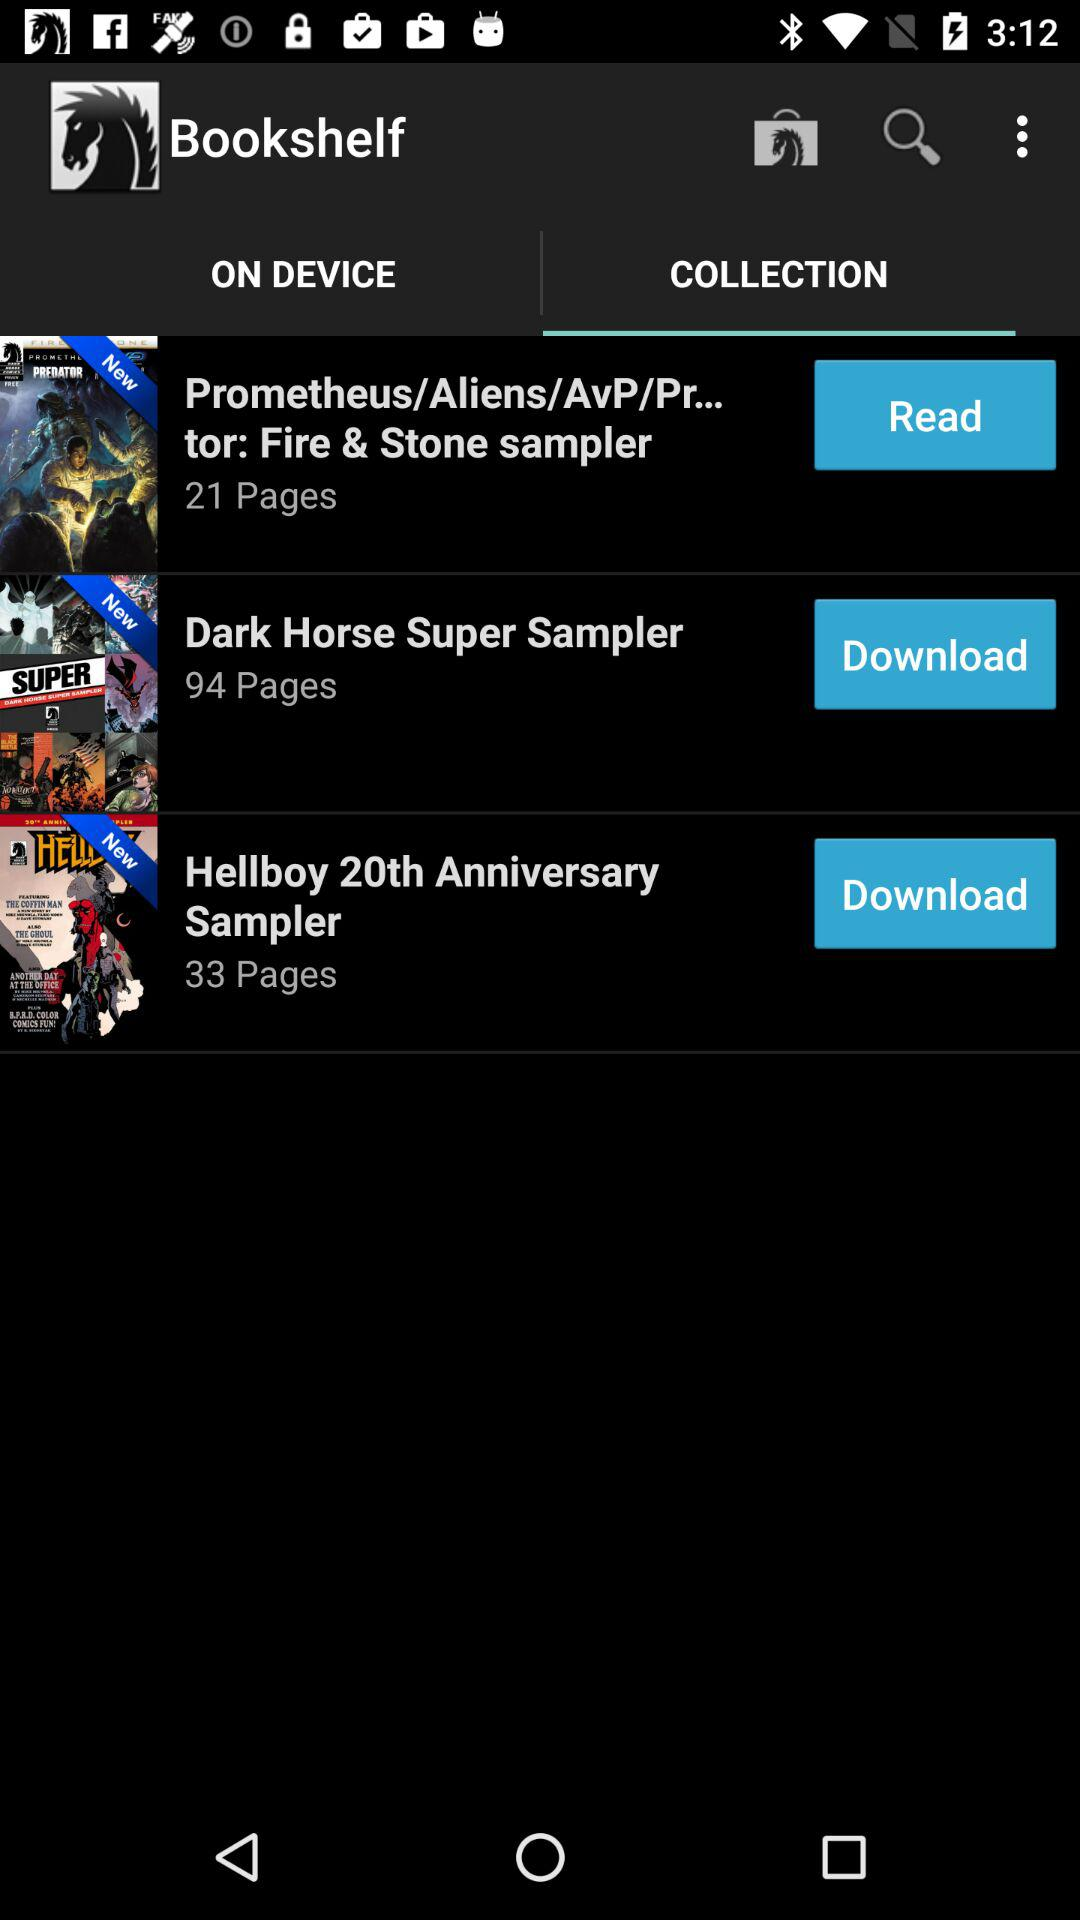How many pages are in the Dark Horse Super Sampler?
Answer the question using a single word or phrase. 94 